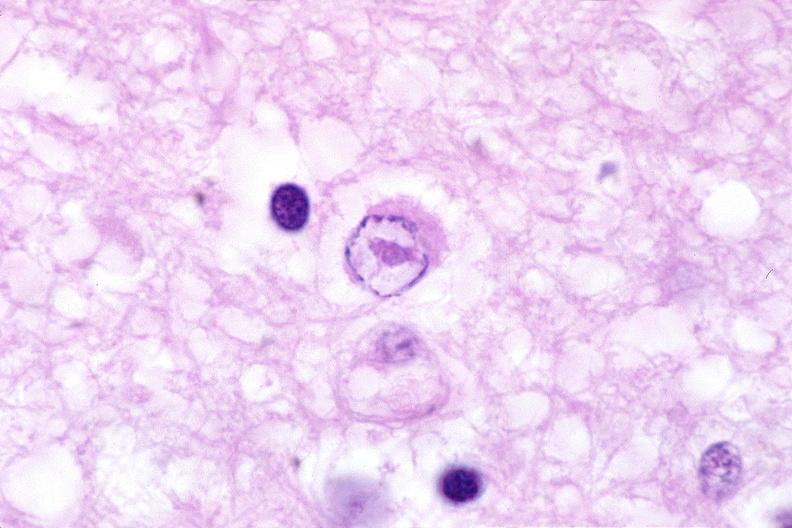does this image show brain, herpes encephalitis with inclusion bodies?
Answer the question using a single word or phrase. Yes 